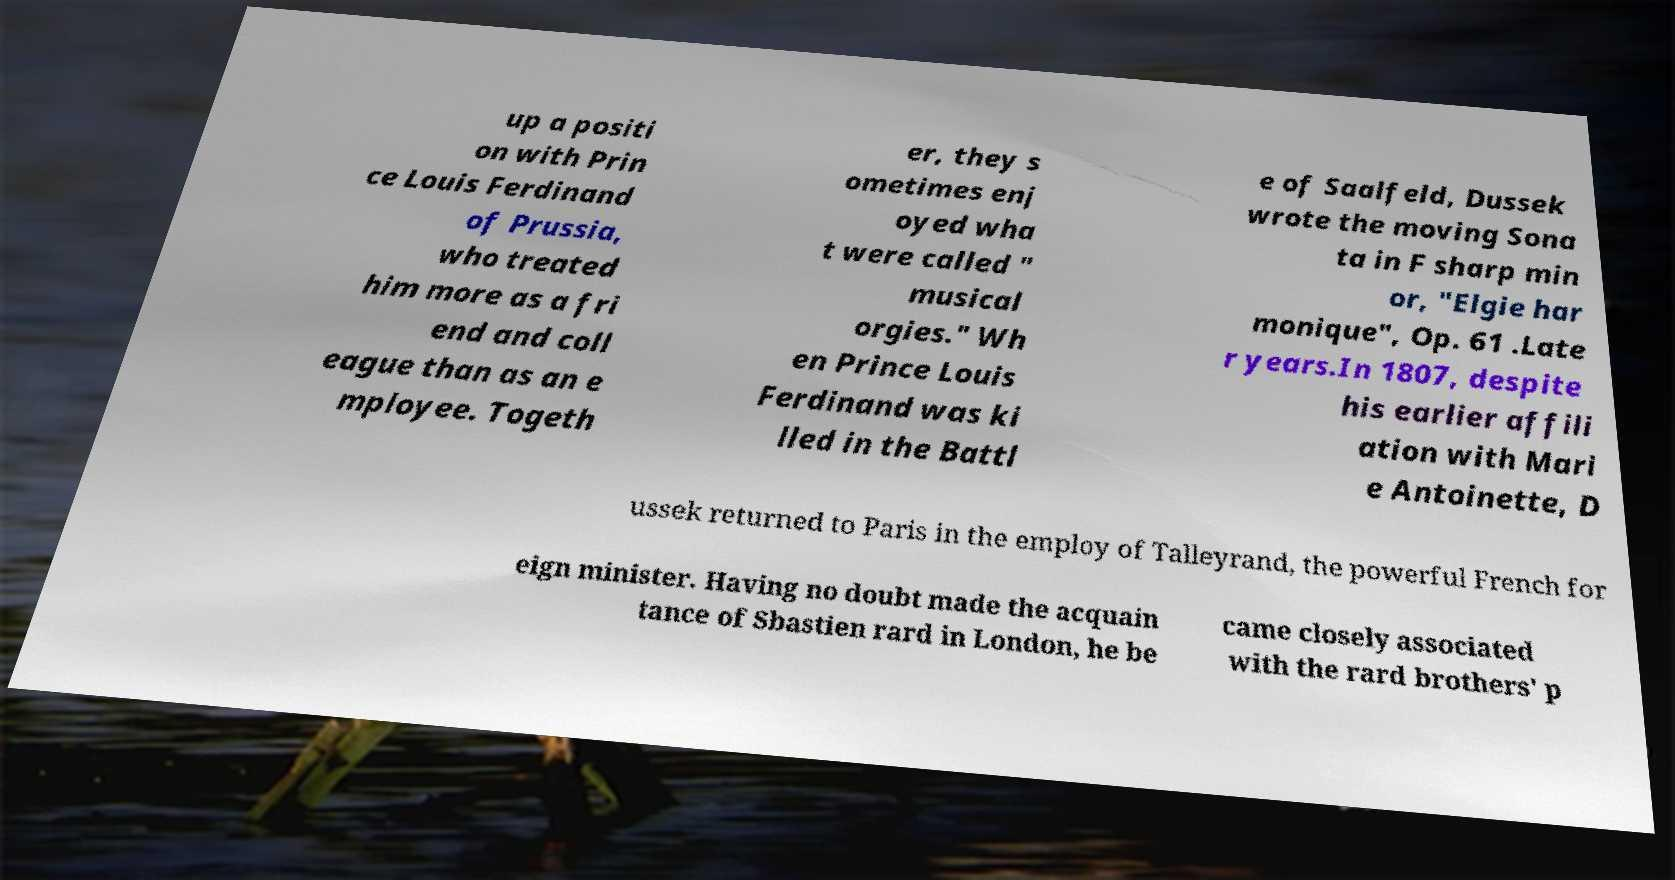Can you read and provide the text displayed in the image?This photo seems to have some interesting text. Can you extract and type it out for me? up a positi on with Prin ce Louis Ferdinand of Prussia, who treated him more as a fri end and coll eague than as an e mployee. Togeth er, they s ometimes enj oyed wha t were called " musical orgies." Wh en Prince Louis Ferdinand was ki lled in the Battl e of Saalfeld, Dussek wrote the moving Sona ta in F sharp min or, "Elgie har monique", Op. 61 .Late r years.In 1807, despite his earlier affili ation with Mari e Antoinette, D ussek returned to Paris in the employ of Talleyrand, the powerful French for eign minister. Having no doubt made the acquain tance of Sbastien rard in London, he be came closely associated with the rard brothers' p 